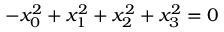<formula> <loc_0><loc_0><loc_500><loc_500>- x _ { 0 } ^ { 2 } + x _ { 1 } ^ { 2 } + x _ { 2 } ^ { 2 } + x _ { 3 } ^ { 2 } = 0</formula> 